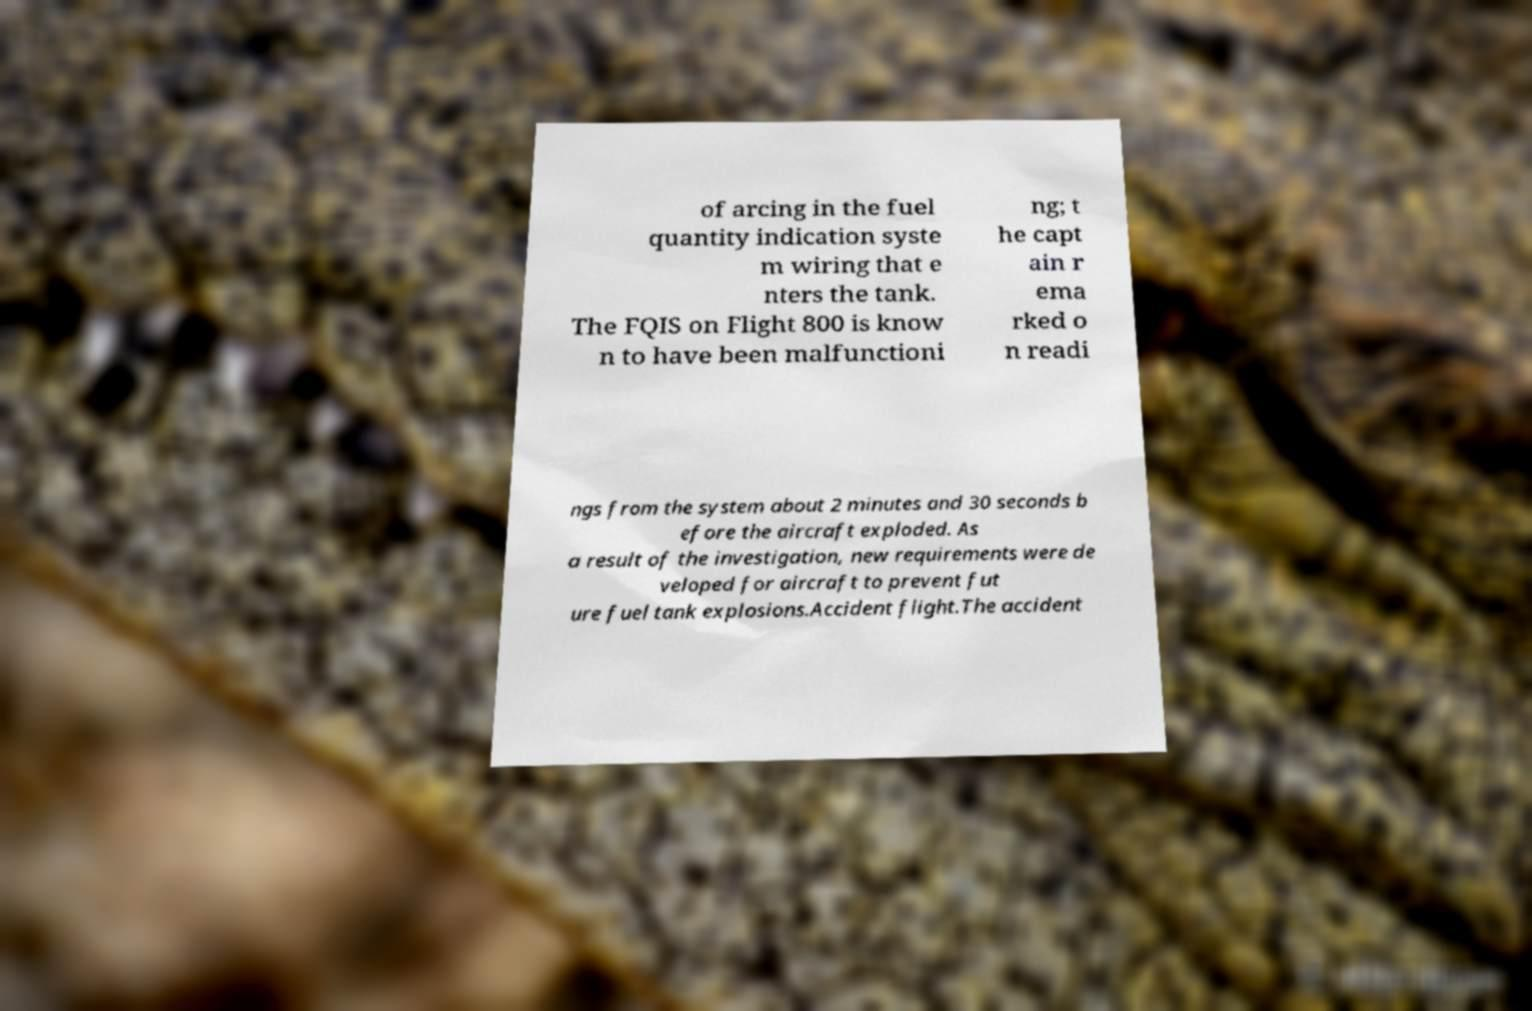There's text embedded in this image that I need extracted. Can you transcribe it verbatim? of arcing in the fuel quantity indication syste m wiring that e nters the tank. The FQIS on Flight 800 is know n to have been malfunctioni ng; t he capt ain r ema rked o n readi ngs from the system about 2 minutes and 30 seconds b efore the aircraft exploded. As a result of the investigation, new requirements were de veloped for aircraft to prevent fut ure fuel tank explosions.Accident flight.The accident 